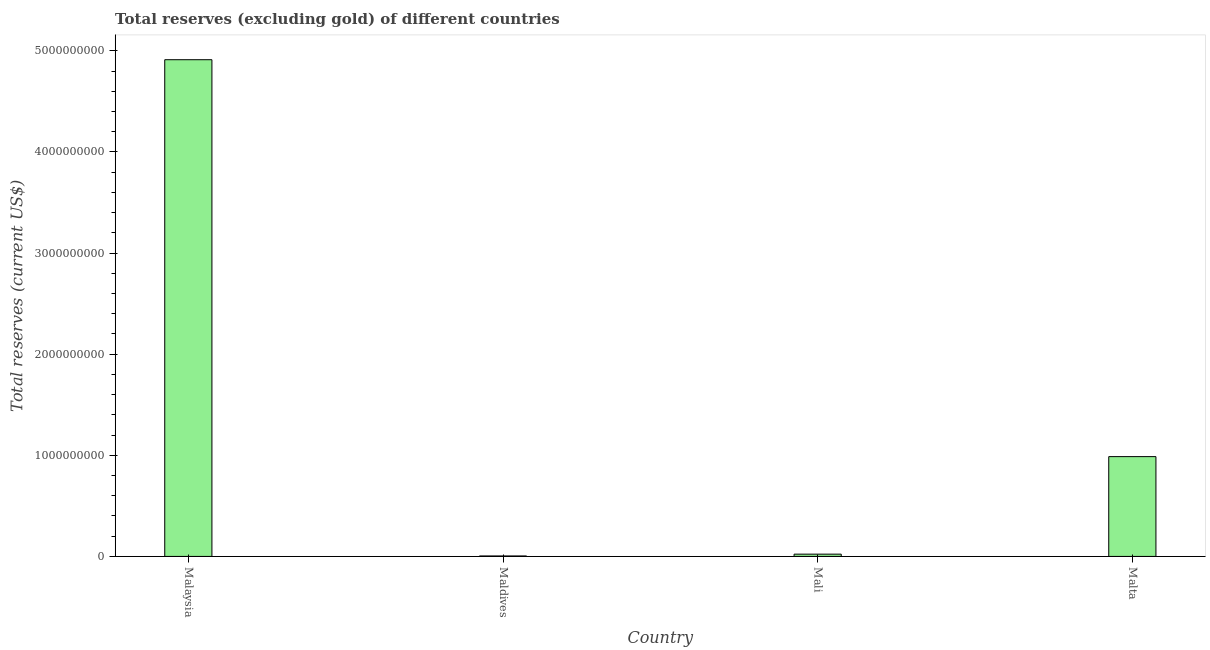Does the graph contain grids?
Provide a short and direct response. No. What is the title of the graph?
Ensure brevity in your answer.  Total reserves (excluding gold) of different countries. What is the label or title of the X-axis?
Provide a short and direct response. Country. What is the label or title of the Y-axis?
Offer a very short reply. Total reserves (current US$). What is the total reserves (excluding gold) in Mali?
Keep it short and to the point. 2.25e+07. Across all countries, what is the maximum total reserves (excluding gold)?
Your response must be concise. 4.91e+09. Across all countries, what is the minimum total reserves (excluding gold)?
Offer a terse response. 4.59e+06. In which country was the total reserves (excluding gold) maximum?
Offer a very short reply. Malaysia. In which country was the total reserves (excluding gold) minimum?
Offer a terse response. Maldives. What is the sum of the total reserves (excluding gold)?
Provide a succinct answer. 5.93e+09. What is the difference between the total reserves (excluding gold) in Mali and Malta?
Make the answer very short. -9.64e+08. What is the average total reserves (excluding gold) per country?
Give a very brief answer. 1.48e+09. What is the median total reserves (excluding gold)?
Ensure brevity in your answer.  5.05e+08. In how many countries, is the total reserves (excluding gold) greater than 3000000000 US$?
Make the answer very short. 1. What is the ratio of the total reserves (excluding gold) in Maldives to that in Malta?
Your answer should be very brief. 0.01. Is the total reserves (excluding gold) in Malaysia less than that in Maldives?
Offer a terse response. No. What is the difference between the highest and the second highest total reserves (excluding gold)?
Give a very brief answer. 3.92e+09. Is the sum of the total reserves (excluding gold) in Malaysia and Maldives greater than the maximum total reserves (excluding gold) across all countries?
Keep it short and to the point. Yes. What is the difference between the highest and the lowest total reserves (excluding gold)?
Offer a terse response. 4.91e+09. Are all the bars in the graph horizontal?
Provide a short and direct response. No. How many countries are there in the graph?
Give a very brief answer. 4. What is the Total reserves (current US$) in Malaysia?
Your answer should be very brief. 4.91e+09. What is the Total reserves (current US$) in Maldives?
Provide a short and direct response. 4.59e+06. What is the Total reserves (current US$) in Mali?
Your response must be concise. 2.25e+07. What is the Total reserves (current US$) in Malta?
Provide a short and direct response. 9.87e+08. What is the difference between the Total reserves (current US$) in Malaysia and Maldives?
Provide a succinct answer. 4.91e+09. What is the difference between the Total reserves (current US$) in Malaysia and Mali?
Provide a short and direct response. 4.89e+09. What is the difference between the Total reserves (current US$) in Malaysia and Malta?
Keep it short and to the point. 3.92e+09. What is the difference between the Total reserves (current US$) in Maldives and Mali?
Your response must be concise. -1.79e+07. What is the difference between the Total reserves (current US$) in Maldives and Malta?
Make the answer very short. -9.82e+08. What is the difference between the Total reserves (current US$) in Mali and Malta?
Offer a very short reply. -9.64e+08. What is the ratio of the Total reserves (current US$) in Malaysia to that in Maldives?
Provide a short and direct response. 1069.66. What is the ratio of the Total reserves (current US$) in Malaysia to that in Mali?
Your answer should be compact. 218.14. What is the ratio of the Total reserves (current US$) in Malaysia to that in Malta?
Ensure brevity in your answer.  4.98. What is the ratio of the Total reserves (current US$) in Maldives to that in Mali?
Offer a very short reply. 0.2. What is the ratio of the Total reserves (current US$) in Maldives to that in Malta?
Your answer should be compact. 0.01. What is the ratio of the Total reserves (current US$) in Mali to that in Malta?
Make the answer very short. 0.02. 